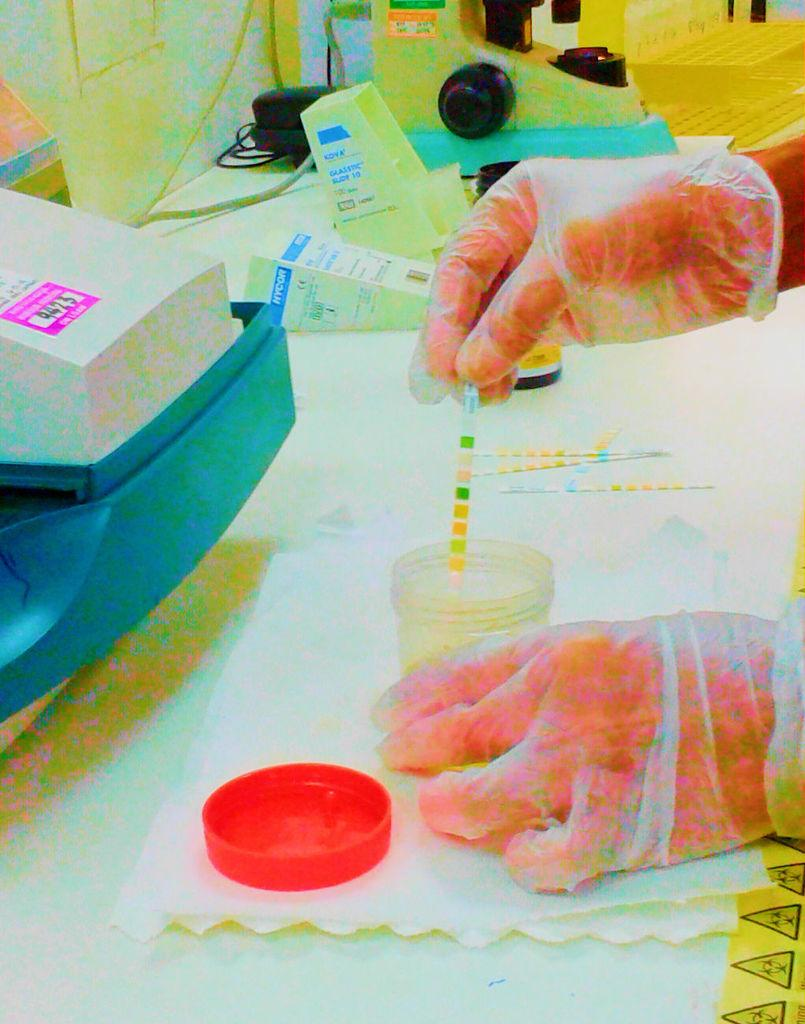What can be seen in the image? There is a person in the image. What is the person holding? The person is holding an object. Can you describe any other objects in the image? There is a box and wire in the image, as well as other objects. How many letters are being delivered by the person in the image? There is no indication of letters or a delivery in the image. 